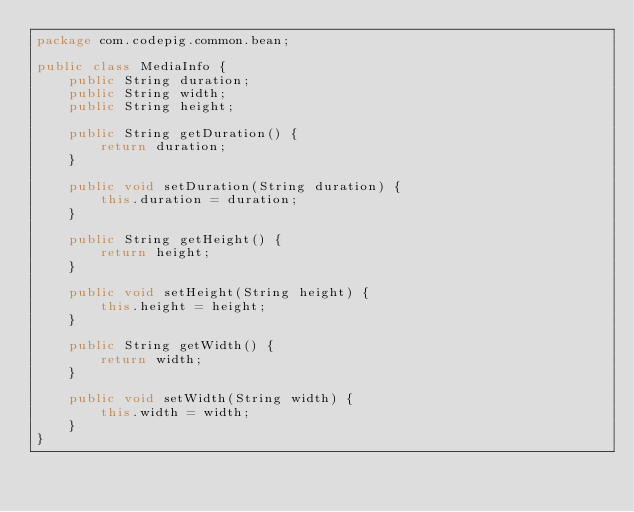Convert code to text. <code><loc_0><loc_0><loc_500><loc_500><_Java_>package com.codepig.common.bean;

public class MediaInfo {
    public String duration;
    public String width;
    public String height;

    public String getDuration() {
        return duration;
    }

    public void setDuration(String duration) {
        this.duration = duration;
    }

    public String getHeight() {
        return height;
    }

    public void setHeight(String height) {
        this.height = height;
    }

    public String getWidth() {
        return width;
    }

    public void setWidth(String width) {
        this.width = width;
    }
}
</code> 